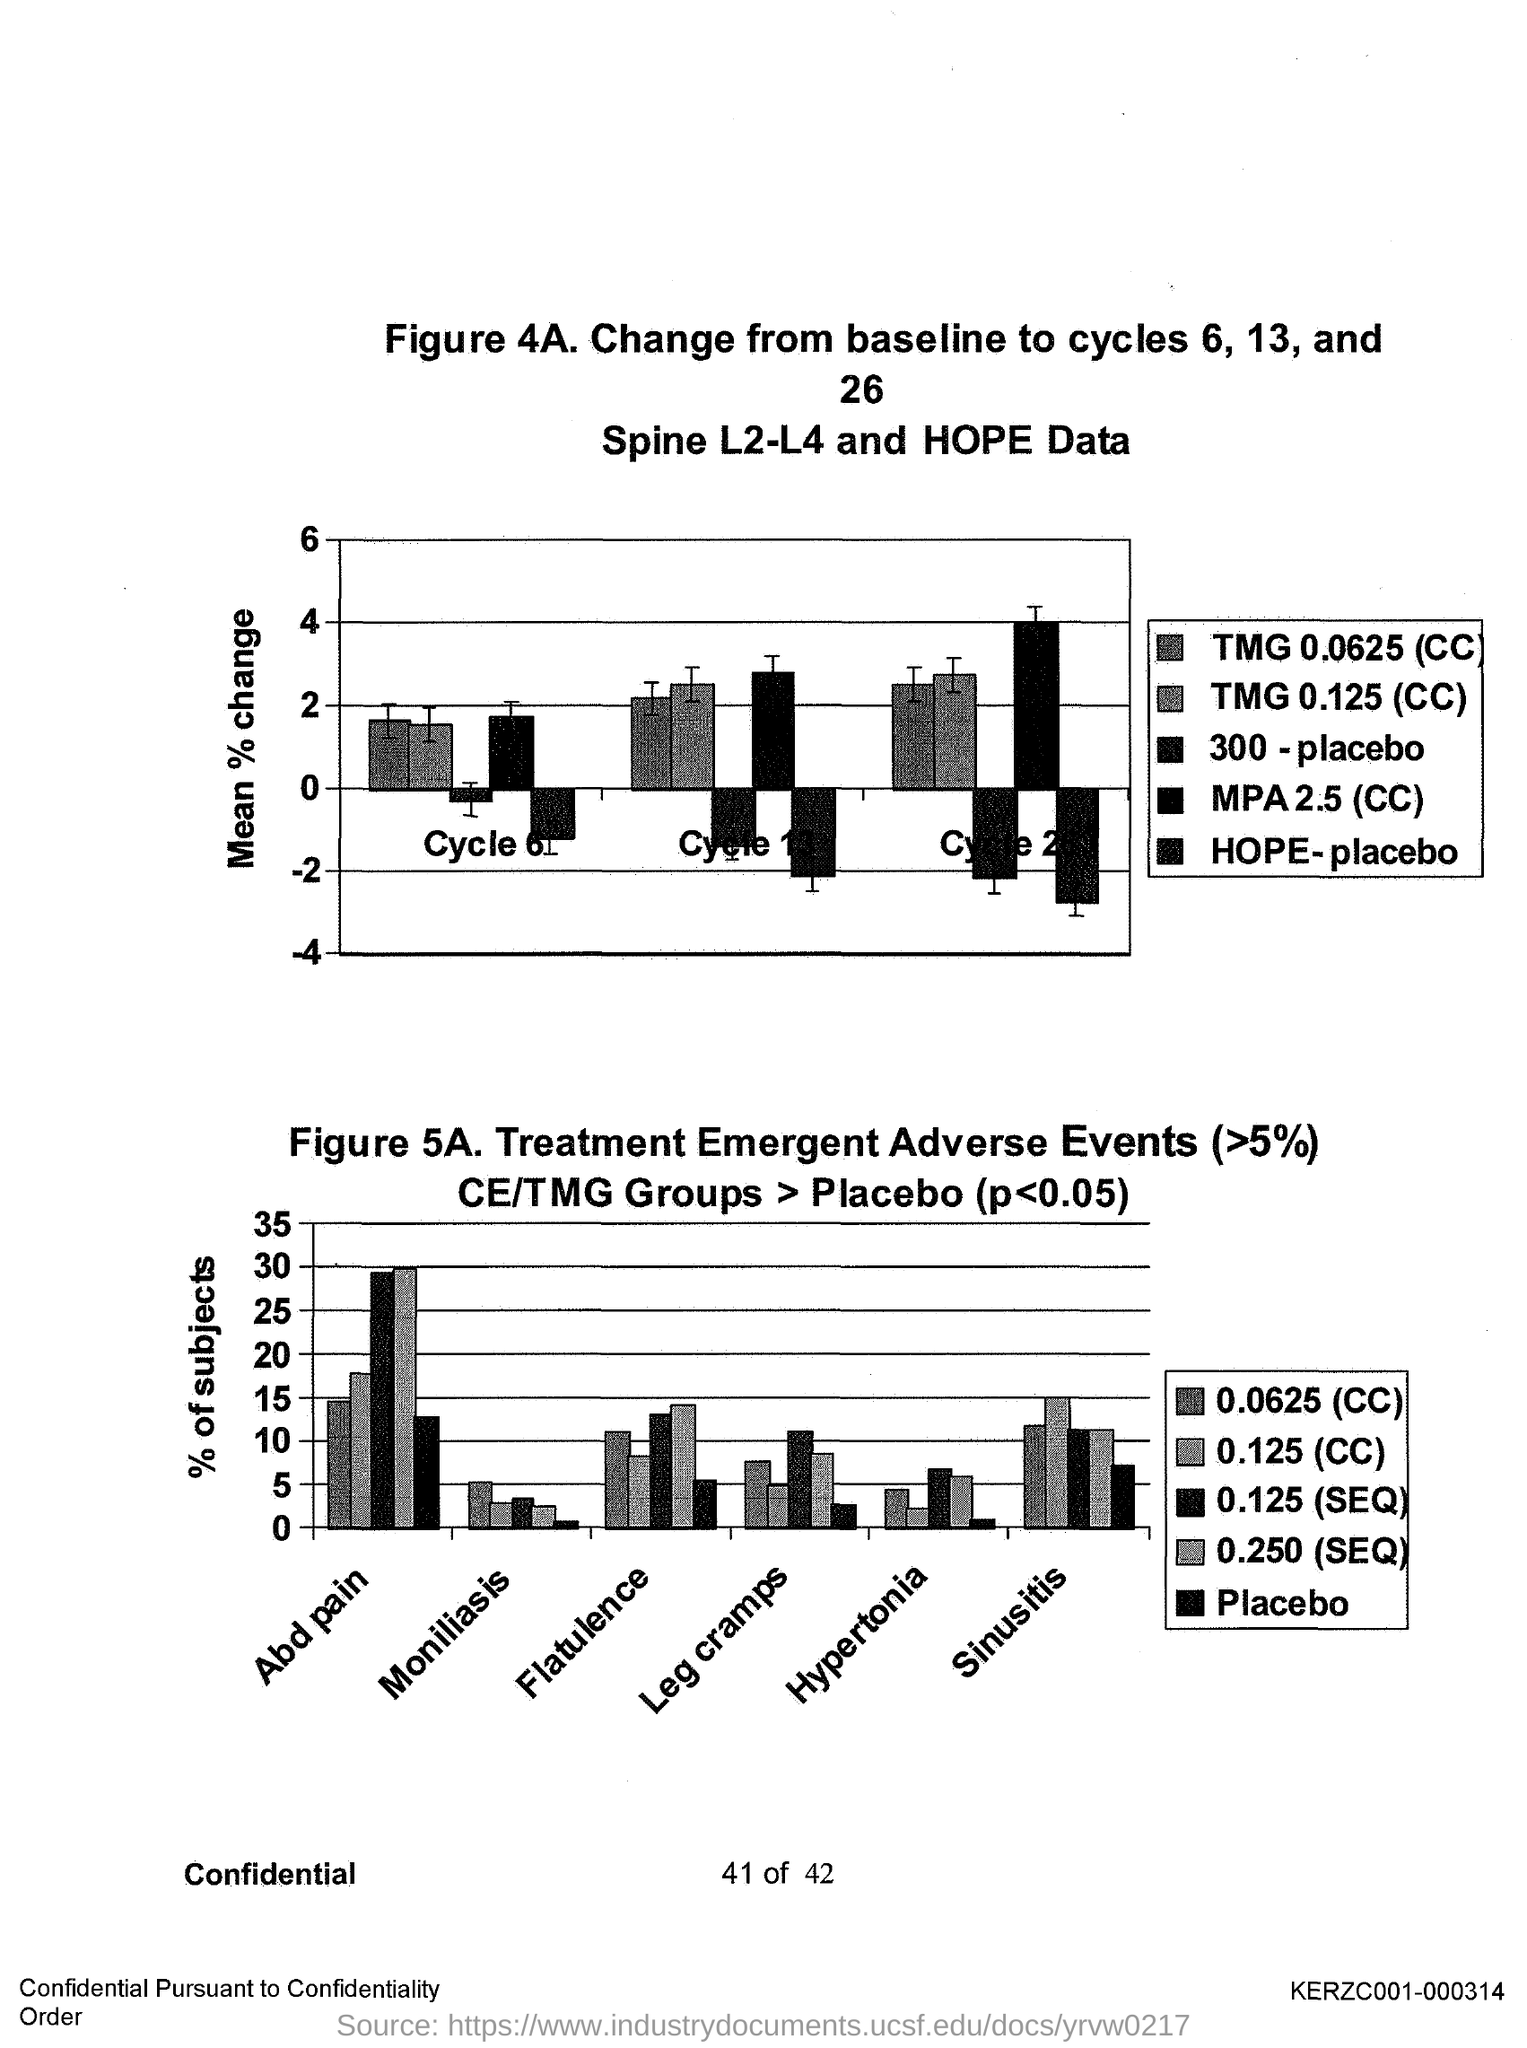What is the unit on Y axis of the graph in Figure 4A.?
Provide a short and direct response. Mean % change. What is the unit on Y axis of the graph in Figure 5A.?
Provide a short and direct response. % of subjects. 